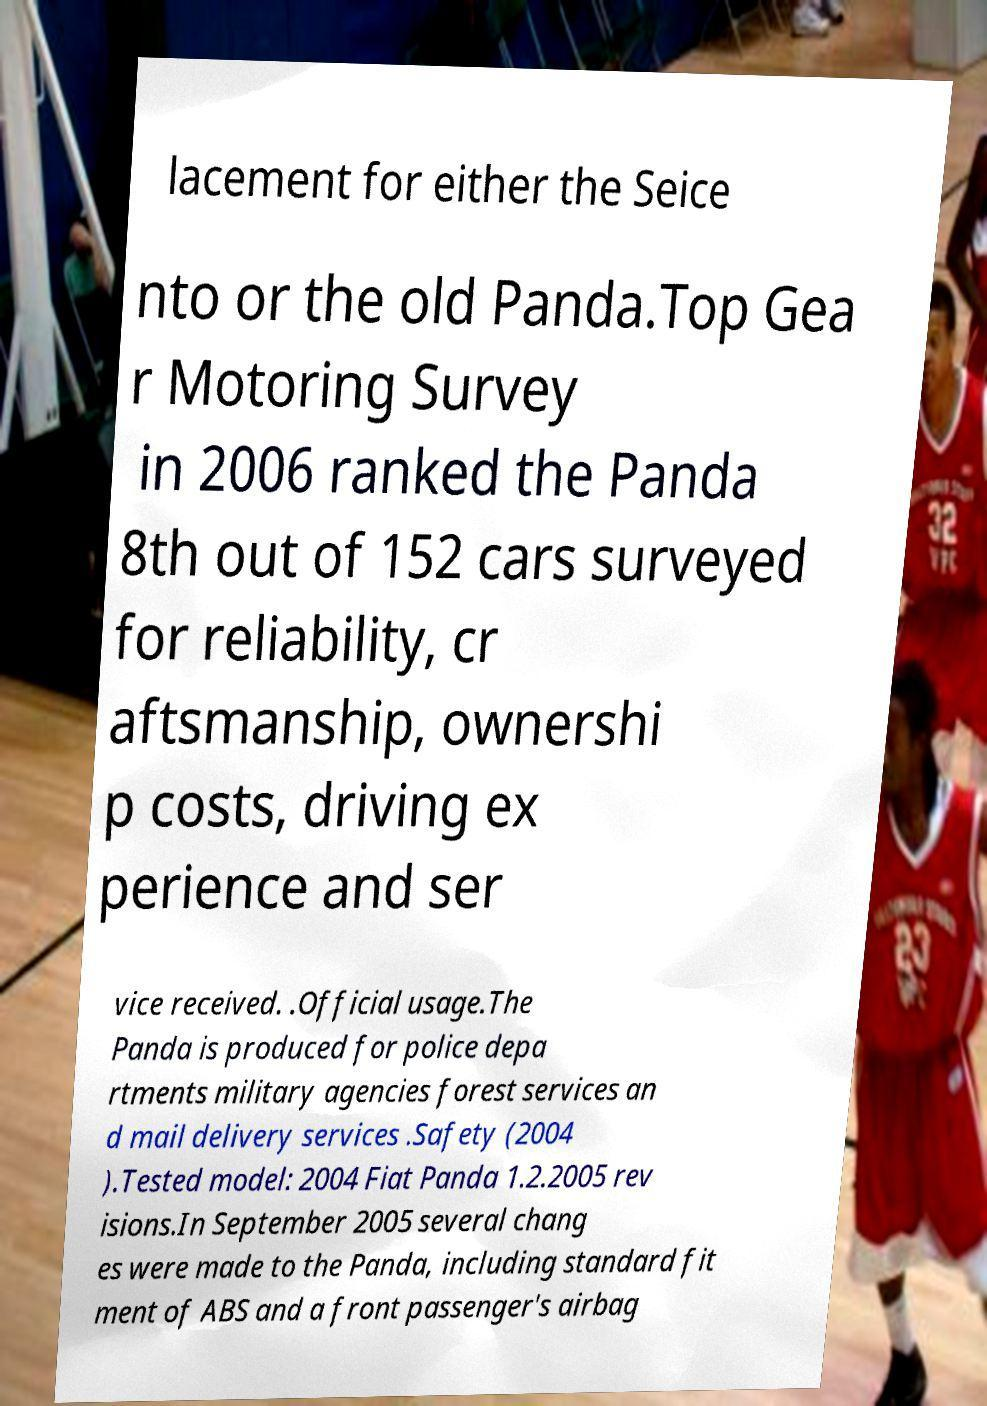What messages or text are displayed in this image? I need them in a readable, typed format. lacement for either the Seice nto or the old Panda.Top Gea r Motoring Survey in 2006 ranked the Panda 8th out of 152 cars surveyed for reliability, cr aftsmanship, ownershi p costs, driving ex perience and ser vice received. .Official usage.The Panda is produced for police depa rtments military agencies forest services an d mail delivery services .Safety (2004 ).Tested model: 2004 Fiat Panda 1.2.2005 rev isions.In September 2005 several chang es were made to the Panda, including standard fit ment of ABS and a front passenger's airbag 